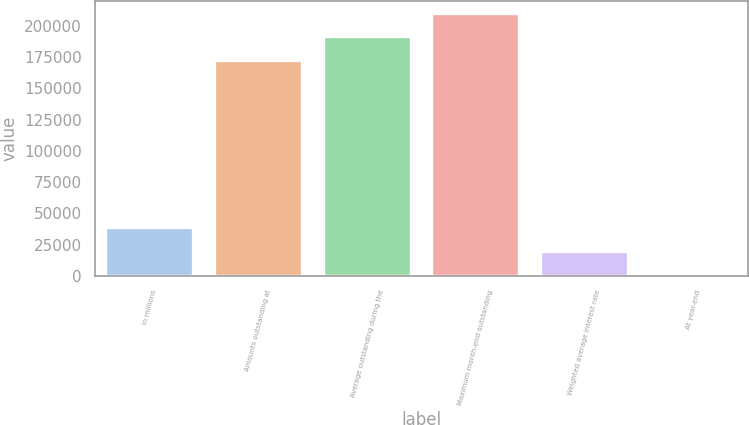<chart> <loc_0><loc_0><loc_500><loc_500><bar_chart><fcel>in millions<fcel>Amounts outstanding at<fcel>Average outstanding during the<fcel>Maximum month-end outstanding<fcel>Weighted average interest rate<fcel>At year-end<nl><fcel>38090.9<fcel>171684<fcel>190729<fcel>209775<fcel>19045.7<fcel>0.39<nl></chart> 